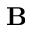<formula> <loc_0><loc_0><loc_500><loc_500>B</formula> 